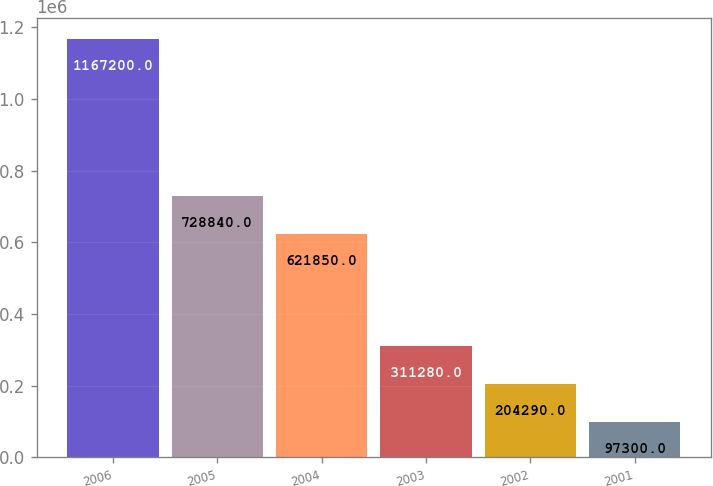Convert chart to OTSL. <chart><loc_0><loc_0><loc_500><loc_500><bar_chart><fcel>2006<fcel>2005<fcel>2004<fcel>2003<fcel>2002<fcel>2001<nl><fcel>1.1672e+06<fcel>728840<fcel>621850<fcel>311280<fcel>204290<fcel>97300<nl></chart> 